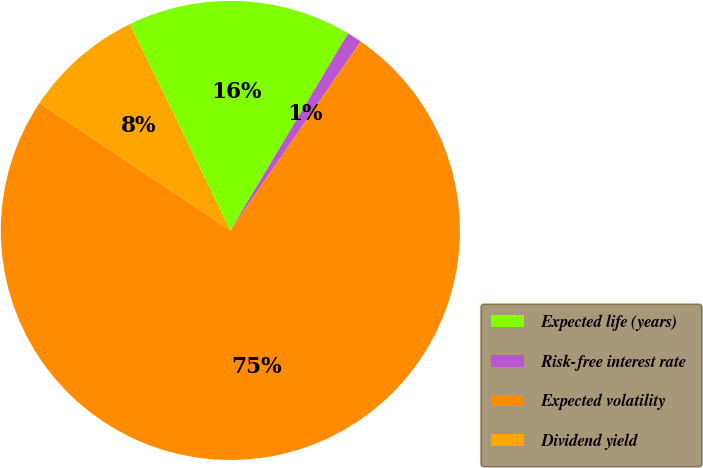Convert chart. <chart><loc_0><loc_0><loc_500><loc_500><pie_chart><fcel>Expected life (years)<fcel>Risk-free interest rate<fcel>Expected volatility<fcel>Dividend yield<nl><fcel>15.79%<fcel>1.04%<fcel>74.76%<fcel>8.41%<nl></chart> 